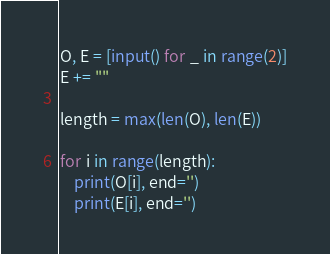Convert code to text. <code><loc_0><loc_0><loc_500><loc_500><_Python_>O, E = [input() for _ in range(2)]
E += ""

length = max(len(O), len(E))

for i in range(length):
    print(O[i], end='')
    print(E[i], end='')
</code> 